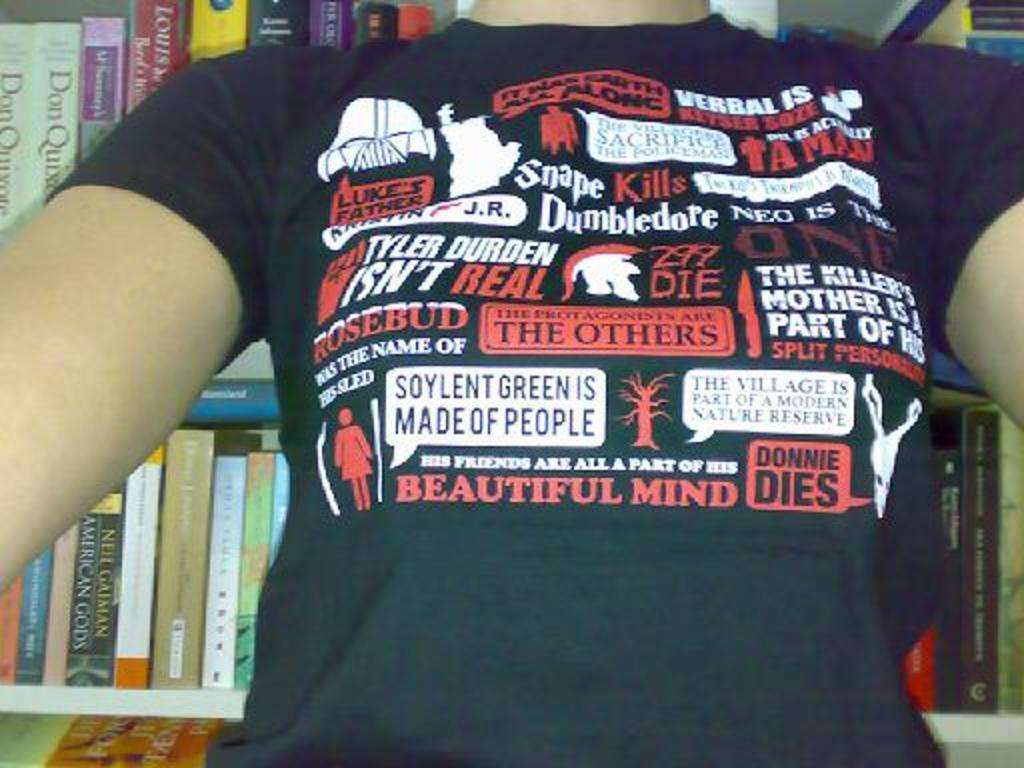Provide a one-sentence caption for the provided image. A black shirt with phrases such as Donnie Dies and Dumbledore on it. 